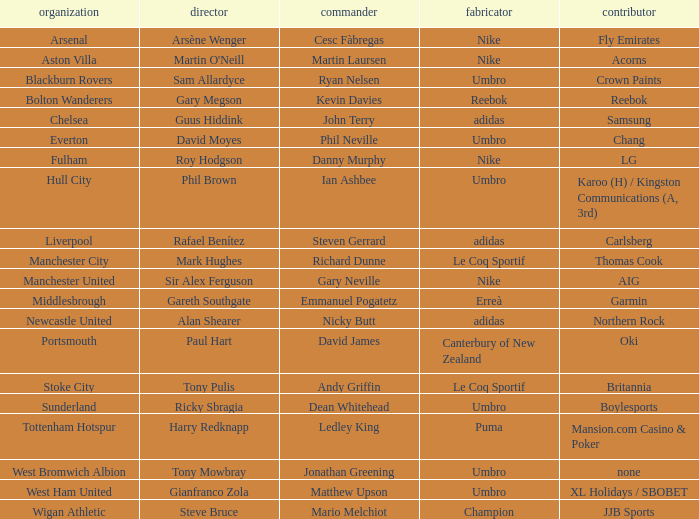Who is the captain of Middlesbrough? Emmanuel Pogatetz. 